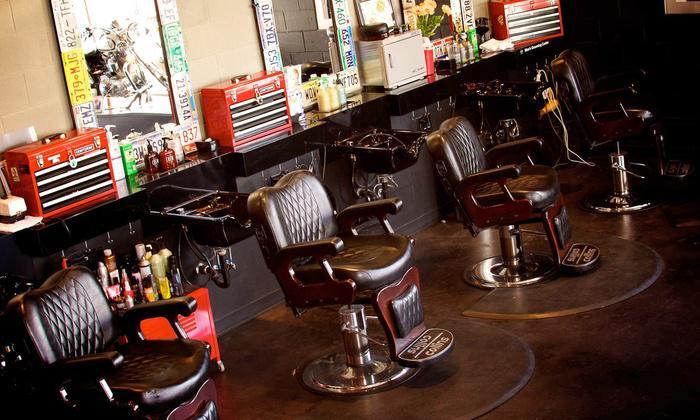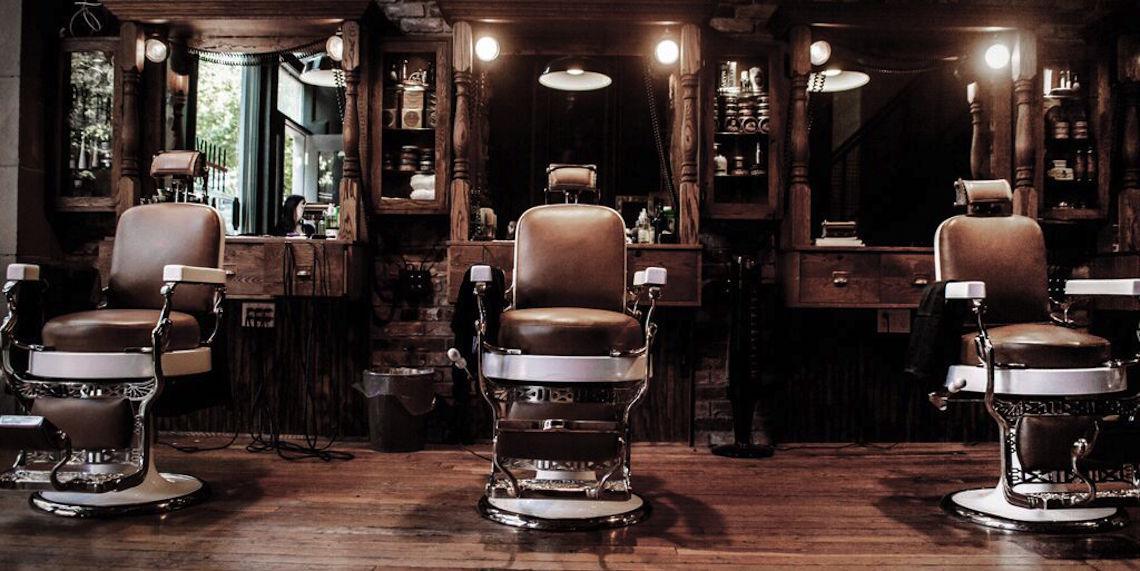The first image is the image on the left, the second image is the image on the right. Evaluate the accuracy of this statement regarding the images: "There are exactly two barber chairs in the image on the right.". Is it true? Answer yes or no. No. The first image is the image on the left, the second image is the image on the right. Considering the images on both sides, is "One image shows a barber shop with a black and white checkerboard floor." valid? Answer yes or no. No. 